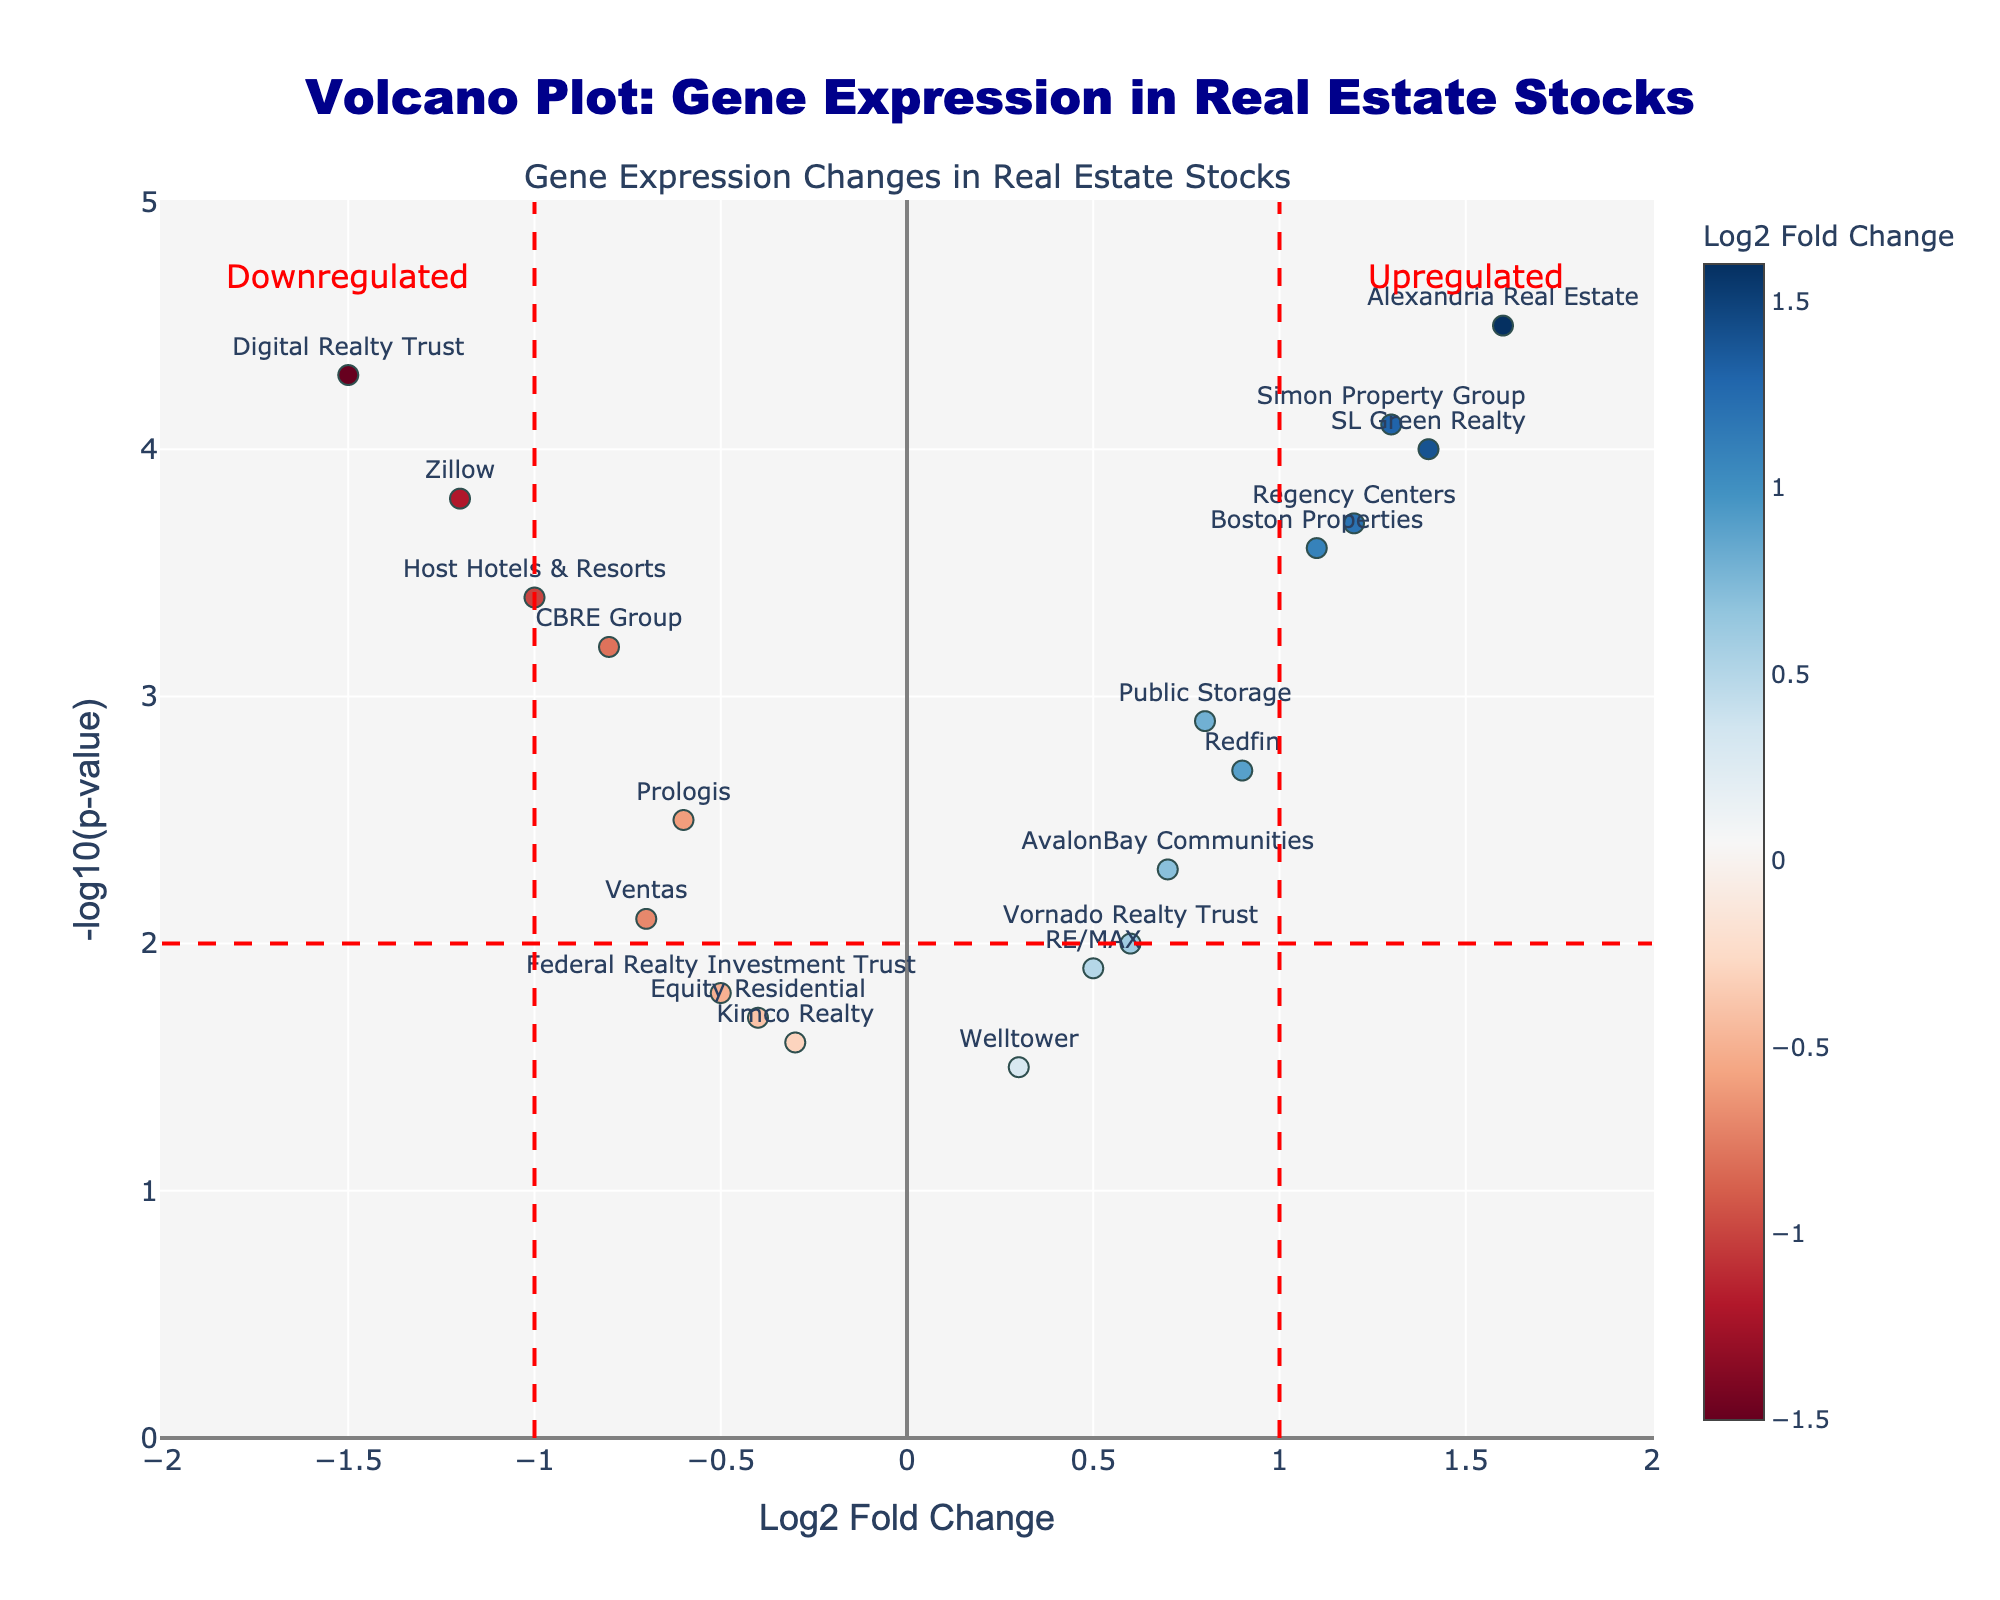How many data points (stocks) are represented in the plot? Count the number of different points or labels present in the plot. Each point represents one stock.
Answer: 19 What is the title of the plot? Look at the top center of the plot where the main heading is displayed.
Answer: Volcano Plot: Gene Expression in Real Estate Stocks Which stock has the highest -log10(p-value)? Compare the y-axis values (Negative Log10 PValue) for all data points to find the highest point.
Answer: Alexandria Real Estate Which stocks are considered downregulated according to the plot's annotations? Look at the left side of the vertical threshold line (Log2 Fold Change < -1), which indicates downregulated stocks.
Answer: Digital Realty Trust, Zillow, Host Hotels & Resorts How many stocks have a log2 fold change greater than 1 and a -log10(p-value) higher than 3? Count the number of points that lie to the right of the vertical threshold line (Log2 Fold Change > 1) and above the horizontal line (Negative Log10 PValue > 3).
Answer: 3 Compare the Log2 fold change of Boston Properties and CBRE Group. Which one has a higher value? Locate both stocks on the x-axis (Log2 Fold Change) and compare the values directly.
Answer: Boston Properties What can be inferred about the expression of Simon Property Group based on its position on the plot? Simon Property Group has a positive Log2 Fold Change and a high -log10(p-value), indicating it is upregulated and statistically significant.
Answer: Upregulated and significant Which stocks are found near the center of the plot, and what does this indicate? Look for stocks around the Log2 Fold Change of 0 and moderate -log10(p-values), indicating minimal change in expression.
Answer: RE/MAX, Welltower Explain the significance of the red dashed lines in the plot. The vertical lines at Log2 Fold Change of -1 and 1 indicate thresholds for significant downregulation and upregulation, respectively. The horizontal line indicates a -log10(p-value) threshold of 2 for significance.
Answer: Thresholds for significance Which stocks have a -log10(p-value) less than 2 and what does this indicate about their expression changes? Identify stocks below the horizontal threshold line (-log10(p-value) < 2), indicating their expression changes are not statistically significant.
Answer: Equity Residential, Kimco Realty, Federal Realty Investment Trust 